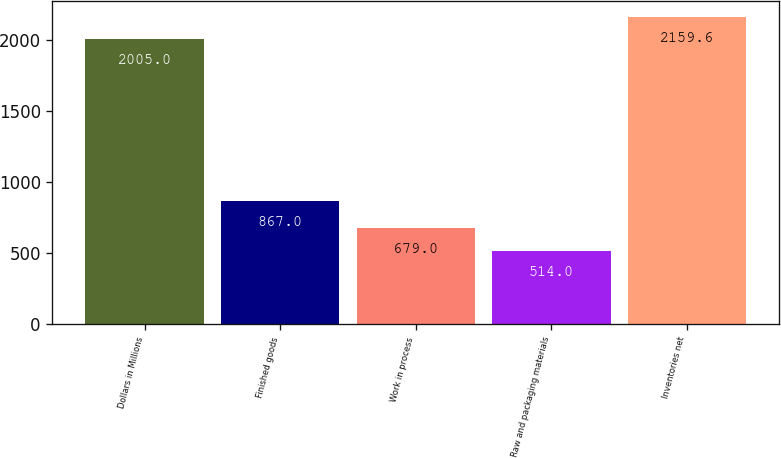Convert chart. <chart><loc_0><loc_0><loc_500><loc_500><bar_chart><fcel>Dollars in Millions<fcel>Finished goods<fcel>Work in process<fcel>Raw and packaging materials<fcel>Inventories net<nl><fcel>2005<fcel>867<fcel>679<fcel>514<fcel>2159.6<nl></chart> 